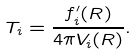<formula> <loc_0><loc_0><loc_500><loc_500>T _ { i } = \frac { f _ { i } ^ { \prime } ( R ) } { 4 \pi V _ { i } ( R ) } .</formula> 